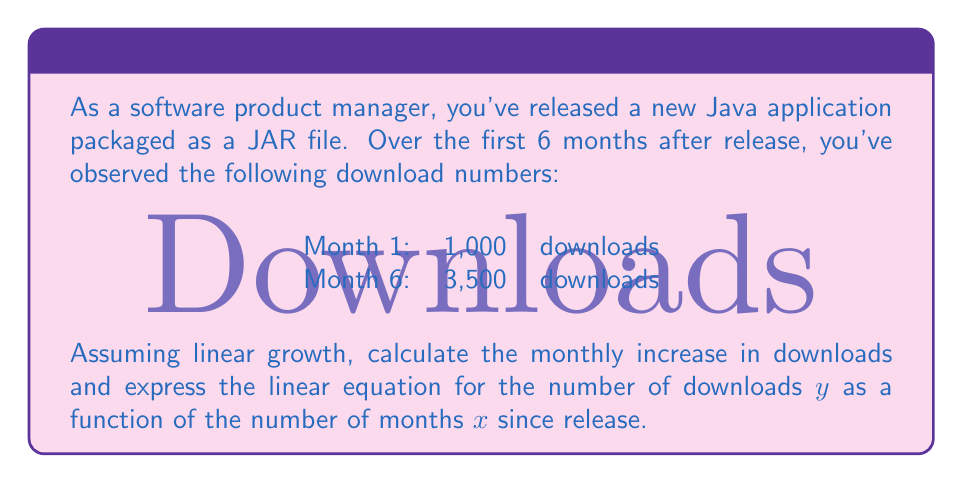Help me with this question. To solve this problem, we'll follow these steps:

1. Calculate the total increase in downloads:
   $$\text{Total increase} = 3,500 - 1,000 = 2,500\text{ downloads}$$

2. Calculate the monthly increase (slope):
   $$\text{Monthly increase} = \frac{\text{Total increase}}{\text{Number of months}} = \frac{2,500}{6-1} = 500\text{ downloads/month}$$

3. Identify the y-intercept (initial downloads):
   $$\text{y-intercept} = 1,000\text{ downloads}$$

4. Form the linear equation using the slope-intercept form:
   $$y = mx + b$$
   Where:
   $m$ = slope (monthly increase)
   $b$ = y-intercept (initial downloads)
   $x$ = number of months since release
   $y$ = number of downloads

   Substituting our values:
   $$y = 500x + 1,000$$

This equation represents the linear growth of JAR file downloads over time, where $x$ is the number of months since release and $y$ is the total number of downloads.
Answer: The monthly increase in downloads is 500 downloads/month.
The linear equation for the number of downloads $y$ as a function of the number of months $x$ since release is:
$$y = 500x + 1,000$$ 